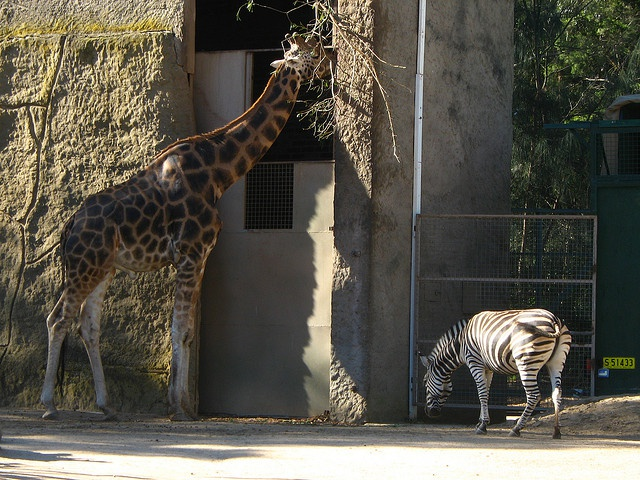Describe the objects in this image and their specific colors. I can see giraffe in gray, black, and maroon tones and zebra in gray, black, ivory, and darkgray tones in this image. 